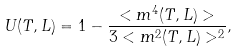Convert formula to latex. <formula><loc_0><loc_0><loc_500><loc_500>U ( T , L ) = 1 - \frac { < m ^ { 4 } ( T , L ) > } { 3 < m ^ { 2 } ( T , L ) > ^ { 2 } } ,</formula> 